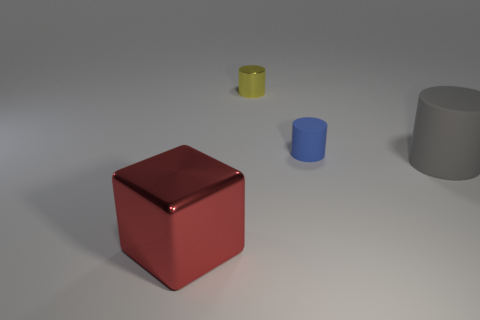What time of day does the lighting in the scene suggest? The lighting in the image has a soft quality with shadows that are not particularly harsh, suggesting it could be an overcast day or interior lighting designed to mimic daylight without creating strong contrasts. 